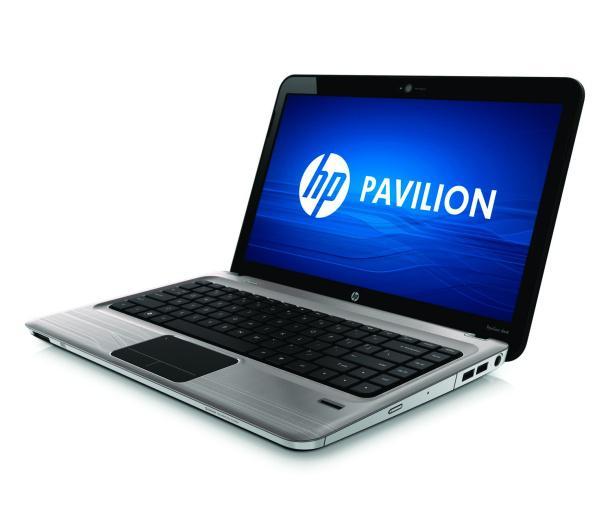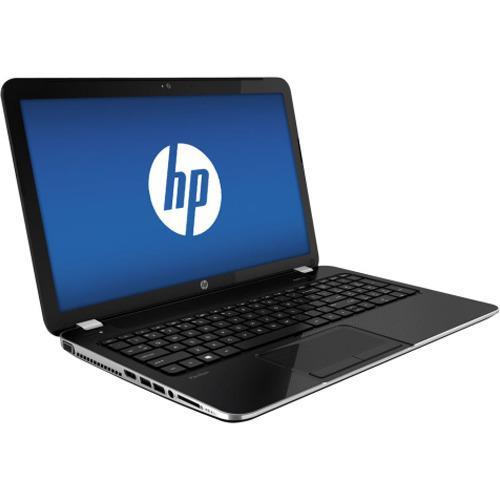The first image is the image on the left, the second image is the image on the right. Examine the images to the left and right. Is the description "At least one image shows a partly open laptop with the screen and keyboard forming less than a 90-degree angle." accurate? Answer yes or no. No. 